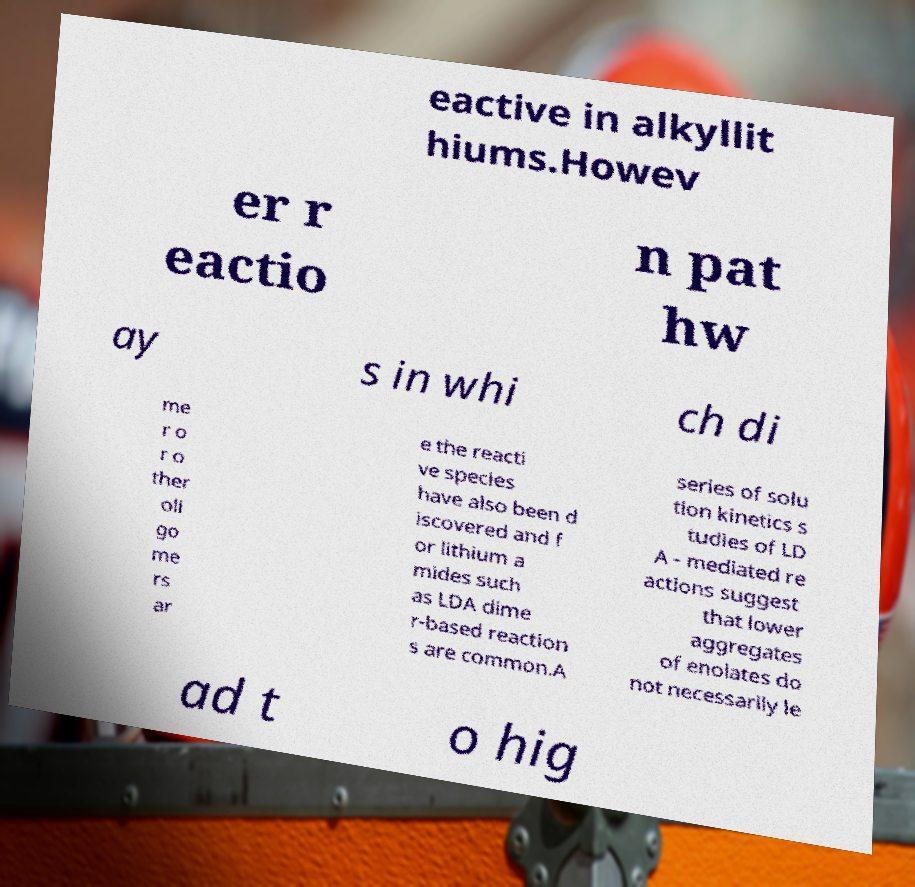For documentation purposes, I need the text within this image transcribed. Could you provide that? eactive in alkyllit hiums.Howev er r eactio n pat hw ay s in whi ch di me r o r o ther oli go me rs ar e the reacti ve species have also been d iscovered and f or lithium a mides such as LDA dime r-based reaction s are common.A series of solu tion kinetics s tudies of LD A - mediated re actions suggest that lower aggregates of enolates do not necessarily le ad t o hig 